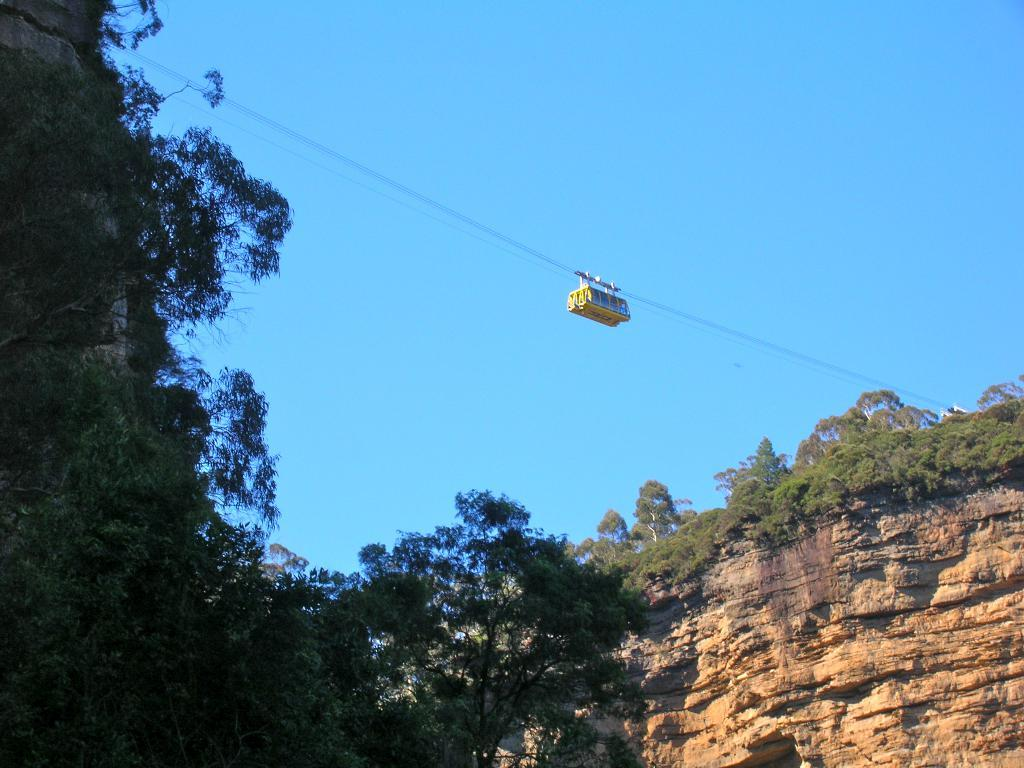What type of vegetation can be seen in the left corner of the image? There are trees in the left corner of the image. What object is present in the image that is not a tree or part of the sky? There is a rock in the image. What type of vegetation can be seen in the right corner of the image? There are trees in the right corner of the image. What mode of transportation is visible in the image? A cable car is visible in the image. What is visible at the top of the image? The sky is visible at the top of the image. What type of feast is being prepared on the rock in the image? There is no feast or any indication of food preparation in the image; it only features trees, a rock, a cable car, and the sky. Can you see any skateboarders in the image? There are no skateboarders or any skateboarding activity depicted in the image. 